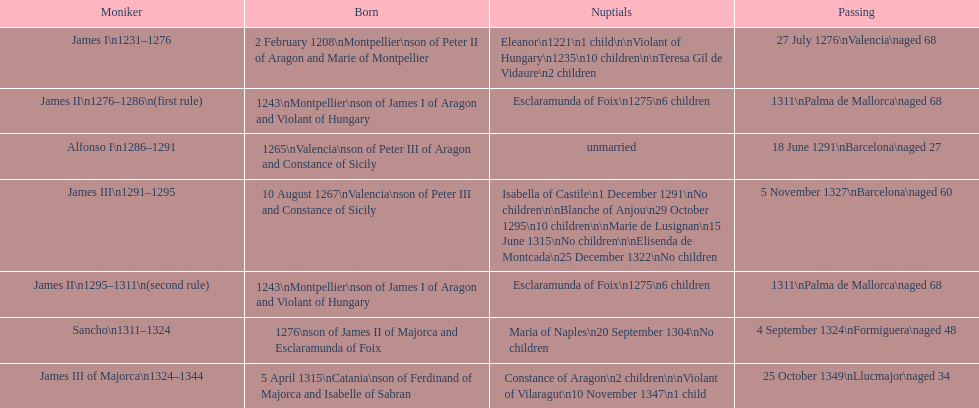Which ruler had the highest number of marriages? James III 1291-1295. 